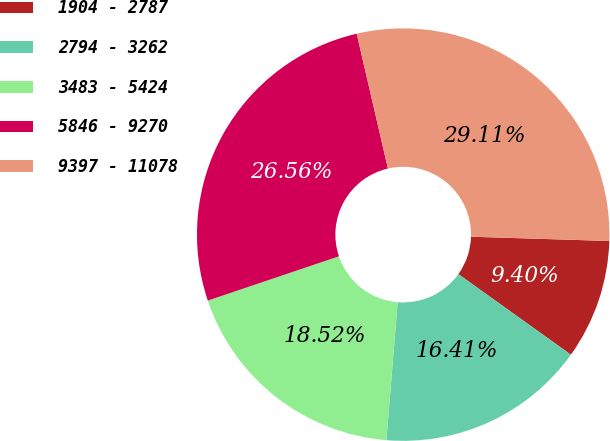Convert chart. <chart><loc_0><loc_0><loc_500><loc_500><pie_chart><fcel>1904 - 2787<fcel>2794 - 3262<fcel>3483 - 5424<fcel>5846 - 9270<fcel>9397 - 11078<nl><fcel>9.4%<fcel>16.41%<fcel>18.52%<fcel>26.56%<fcel>29.11%<nl></chart> 